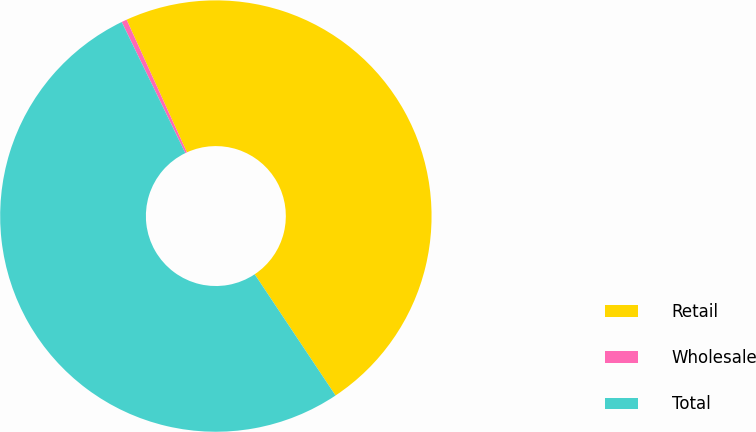Convert chart to OTSL. <chart><loc_0><loc_0><loc_500><loc_500><pie_chart><fcel>Retail<fcel>Wholesale<fcel>Total<nl><fcel>47.43%<fcel>0.4%<fcel>52.17%<nl></chart> 